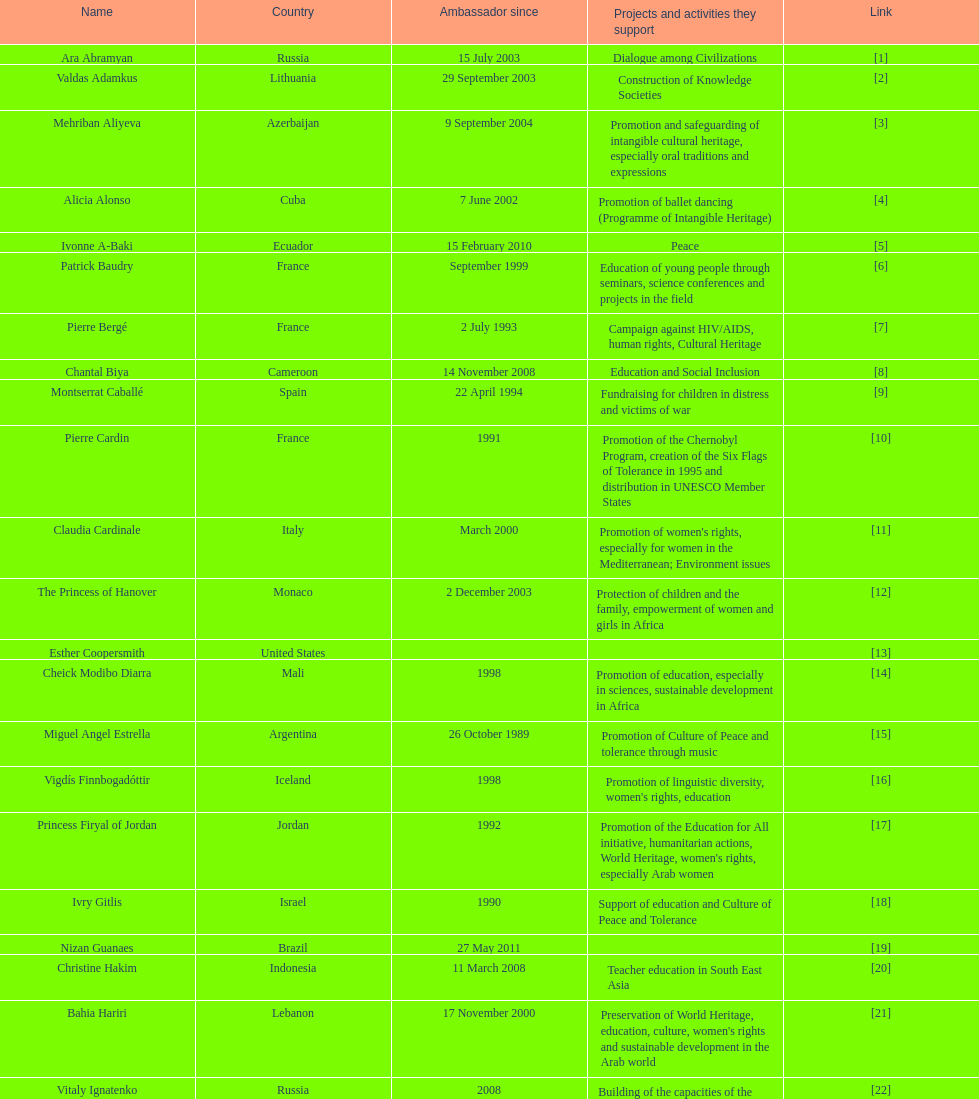Which unesco goodwill ambassador is mainly associated with supporting the chernobyl program? Pierre Cardin. 